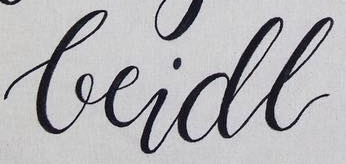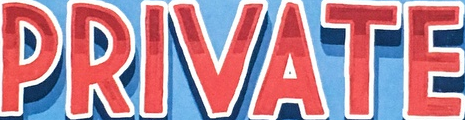Identify the words shown in these images in order, separated by a semicolon. beidl; PRIVATE 